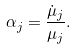<formula> <loc_0><loc_0><loc_500><loc_500>\alpha _ { j } = \frac { \dot { \mu } _ { j } } { \mu _ { j } } .</formula> 